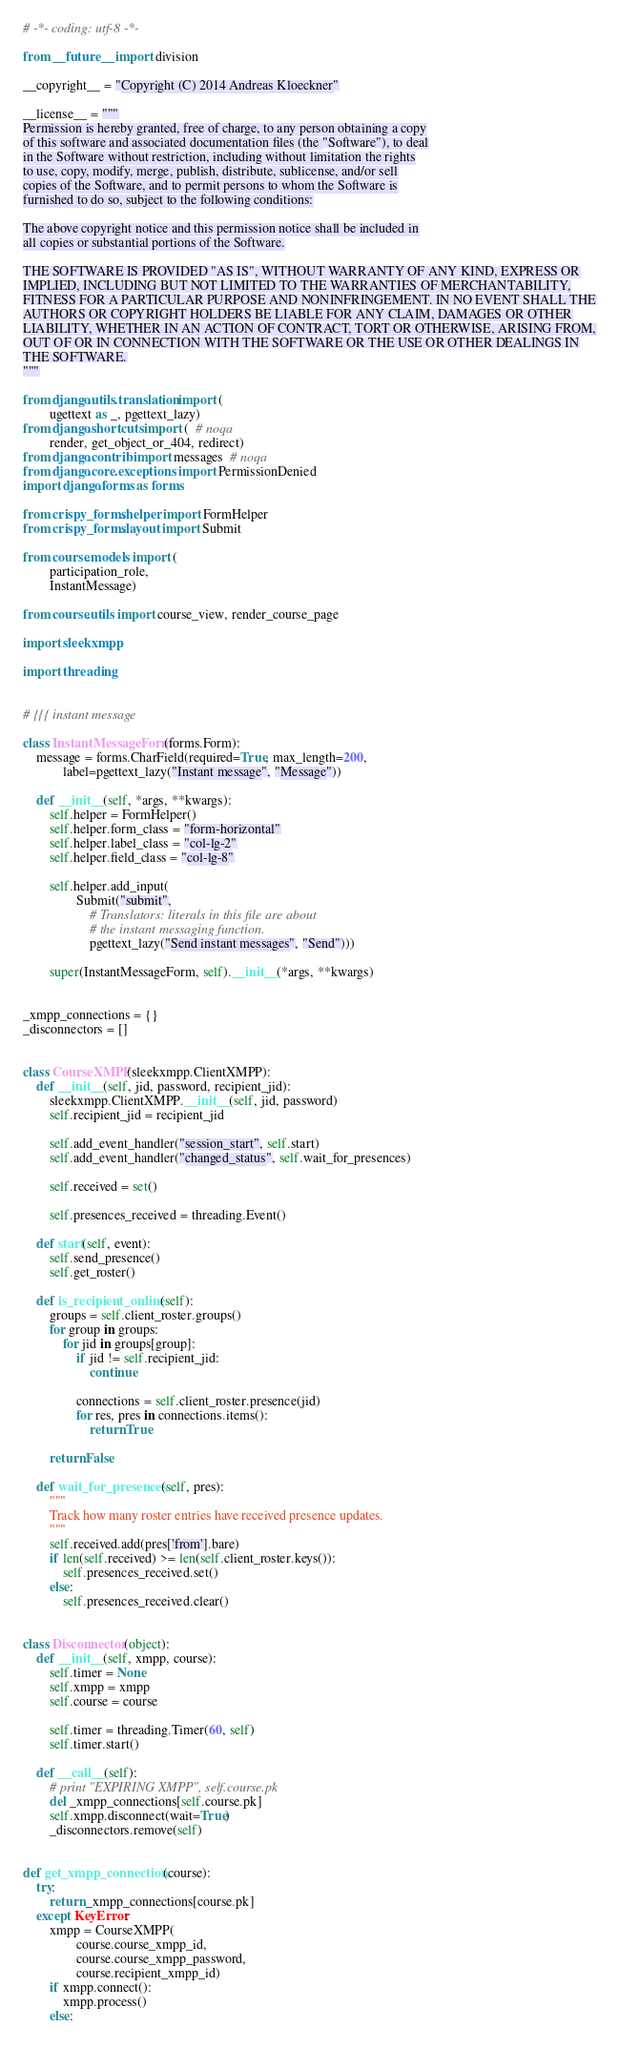<code> <loc_0><loc_0><loc_500><loc_500><_Python_># -*- coding: utf-8 -*-

from __future__ import division

__copyright__ = "Copyright (C) 2014 Andreas Kloeckner"

__license__ = """
Permission is hereby granted, free of charge, to any person obtaining a copy
of this software and associated documentation files (the "Software"), to deal
in the Software without restriction, including without limitation the rights
to use, copy, modify, merge, publish, distribute, sublicense, and/or sell
copies of the Software, and to permit persons to whom the Software is
furnished to do so, subject to the following conditions:

The above copyright notice and this permission notice shall be included in
all copies or substantial portions of the Software.

THE SOFTWARE IS PROVIDED "AS IS", WITHOUT WARRANTY OF ANY KIND, EXPRESS OR
IMPLIED, INCLUDING BUT NOT LIMITED TO THE WARRANTIES OF MERCHANTABILITY,
FITNESS FOR A PARTICULAR PURPOSE AND NONINFRINGEMENT. IN NO EVENT SHALL THE
AUTHORS OR COPYRIGHT HOLDERS BE LIABLE FOR ANY CLAIM, DAMAGES OR OTHER
LIABILITY, WHETHER IN AN ACTION OF CONTRACT, TORT OR OTHERWISE, ARISING FROM,
OUT OF OR IN CONNECTION WITH THE SOFTWARE OR THE USE OR OTHER DEALINGS IN
THE SOFTWARE.
"""

from django.utils.translation import (
        ugettext as _, pgettext_lazy)
from django.shortcuts import (  # noqa
        render, get_object_or_404, redirect)
from django.contrib import messages  # noqa
from django.core.exceptions import PermissionDenied
import django.forms as forms

from crispy_forms.helper import FormHelper
from crispy_forms.layout import Submit

from course.models import (
        participation_role,
        InstantMessage)

from course.utils import course_view, render_course_page

import sleekxmpp

import threading


# {{{ instant message

class InstantMessageForm(forms.Form):
    message = forms.CharField(required=True, max_length=200,
            label=pgettext_lazy("Instant message", "Message"))

    def __init__(self, *args, **kwargs):
        self.helper = FormHelper()
        self.helper.form_class = "form-horizontal"
        self.helper.label_class = "col-lg-2"
        self.helper.field_class = "col-lg-8"

        self.helper.add_input(
                Submit("submit",
                    # Translators: literals in this file are about
                    # the instant messaging function.
                    pgettext_lazy("Send instant messages", "Send")))

        super(InstantMessageForm, self).__init__(*args, **kwargs)


_xmpp_connections = {}
_disconnectors = []


class CourseXMPP(sleekxmpp.ClientXMPP):
    def __init__(self, jid, password, recipient_jid):
        sleekxmpp.ClientXMPP.__init__(self, jid, password)
        self.recipient_jid = recipient_jid

        self.add_event_handler("session_start", self.start)
        self.add_event_handler("changed_status", self.wait_for_presences)

        self.received = set()

        self.presences_received = threading.Event()

    def start(self, event):
        self.send_presence()
        self.get_roster()

    def is_recipient_online(self):
        groups = self.client_roster.groups()
        for group in groups:
            for jid in groups[group]:
                if jid != self.recipient_jid:
                    continue

                connections = self.client_roster.presence(jid)
                for res, pres in connections.items():
                    return True

        return False

    def wait_for_presences(self, pres):
        """
        Track how many roster entries have received presence updates.
        """
        self.received.add(pres['from'].bare)
        if len(self.received) >= len(self.client_roster.keys()):
            self.presences_received.set()
        else:
            self.presences_received.clear()


class Disconnector(object):
    def __init__(self, xmpp, course):
        self.timer = None
        self.xmpp = xmpp
        self.course = course

        self.timer = threading.Timer(60, self)
        self.timer.start()

    def __call__(self):
        # print "EXPIRING XMPP", self.course.pk
        del _xmpp_connections[self.course.pk]
        self.xmpp.disconnect(wait=True)
        _disconnectors.remove(self)


def get_xmpp_connection(course):
    try:
        return _xmpp_connections[course.pk]
    except KeyError:
        xmpp = CourseXMPP(
                course.course_xmpp_id,
                course.course_xmpp_password,
                course.recipient_xmpp_id)
        if xmpp.connect():
            xmpp.process()
        else:</code> 